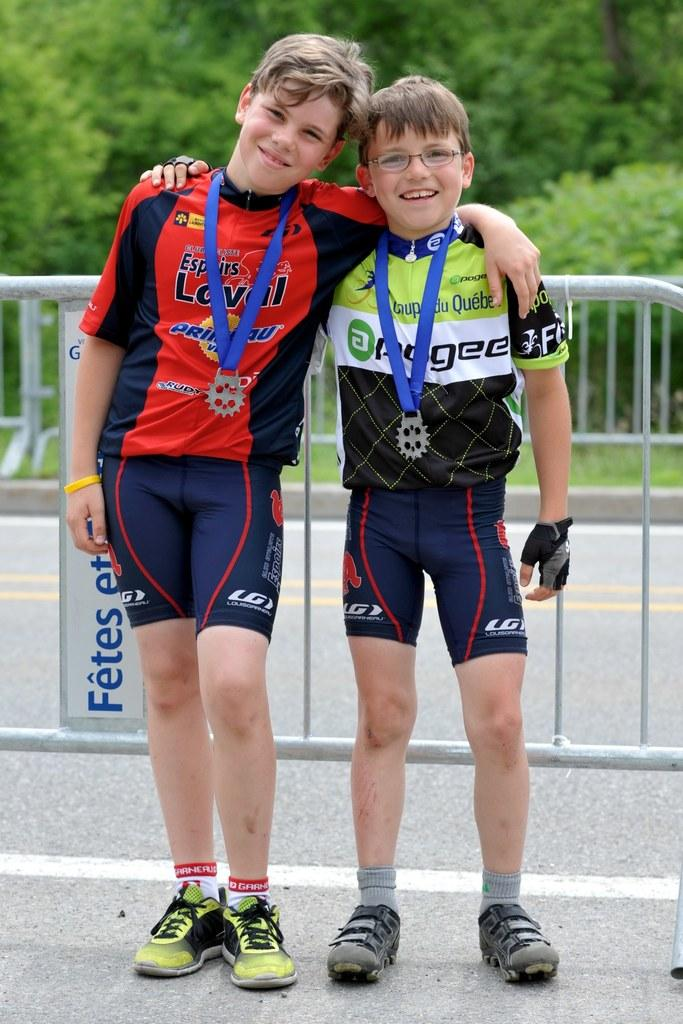<image>
Provide a brief description of the given image. A young athlete poses with a friend while wearing Garneau socks. 